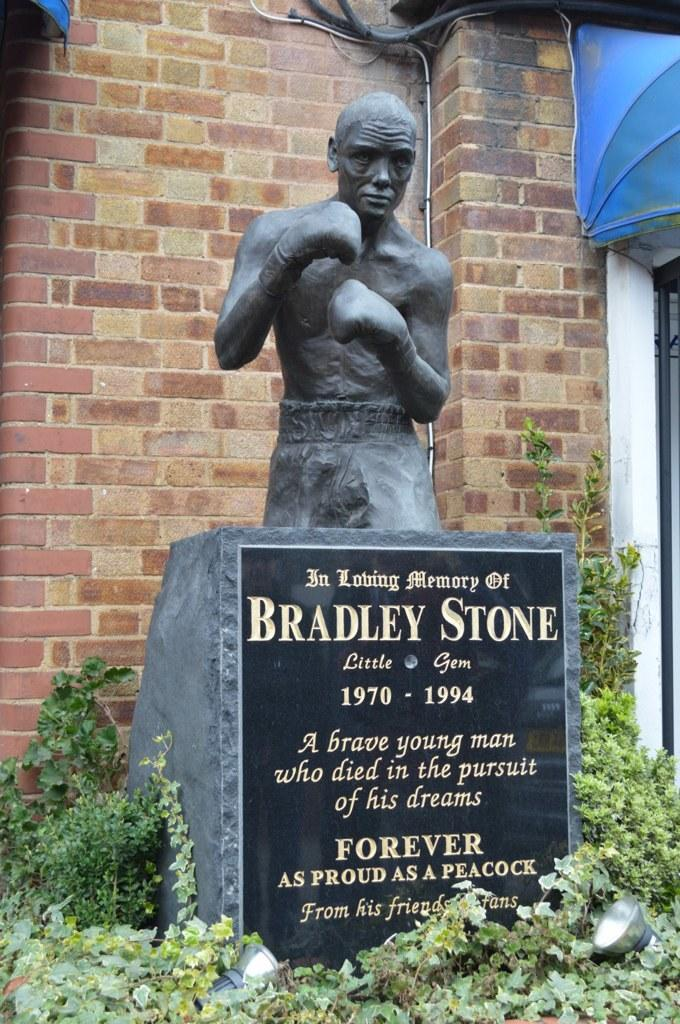What is the main subject of the image? There is a man sculpture on a stone in the image. What can be seen surrounding the stone? There are plants around the stone. What is visible in the background of the image? There is a wall visible behind the stone. Can you see any rifles in the image? There are no rifles present in the image. What type of underwear is the man sculpture wearing in the image? The man sculpture is a sculpture and does not wear underwear. 